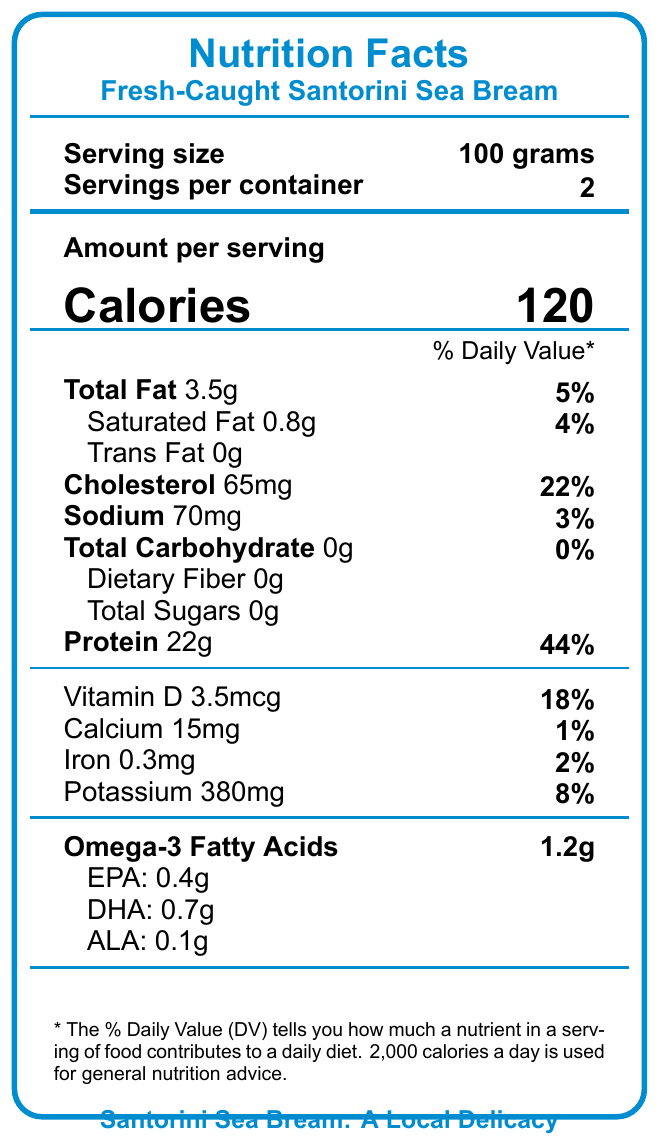how many calories are there per serving? The document lists "Calories" as 120 under the "Amount per serving" section.
Answer: 120 what is the total amount of omega-3 fatty acids in a serving? The "Omega-3 Fatty Acids" section shows a total of 1.2 grams.
Answer: 1.2g how much protein is in a serving of Santorini Sea Bream? The "Protein" amount is listed as 22 grams per serving.
Answer: 22g how much sodium is in one serving, and what is its daily value percentage? The document lists Sodium as 70mg, which is 3% of the daily value.
Answer: 70mg and 3% what is the serving size of Fresh-Caught Santorini Sea Bream? The document specifies the serving size as 100 grams.
Answer: 100 grams what percentage of the daily value is the vitamin D content per serving? Vitamin D amount is given as 18% of the daily value.
Answer: 18% which of the following nutrients is not present in the Fresh-Caught Santorini Sea Bream? A. Trans Fat B. Dietary Fiber C. Total Sugars D. All of the Above The document lists "Trans Fat" as 0g, "Dietary Fiber" as 0g, and "Total Sugars" as 0g, meaning none of these nutrients are present.
Answer: D. All of the Above which nutrient has the highest daily value percentage? A. Protein B. Cholesterol C. Calcium D. Potassium Among the listed nutrients, Protein has the highest daily value percentage at 44%.
Answer: A. Protein does the product contain any trans fat? The document clearly states "Trans Fat 0g".
Answer: No how many servings are per container? The document lists "Servings per container" as 2.
Answer: 2 what is the main idea of the document? The document outlines the nutritional content of Fresh-Caught Santorini Sea Bream, including specific details about its beneficial omega-3 fatty acids and mentions additional facts about the catch method and its local culinary importance.
Answer: The document provides the nutrition facts for Fresh-Caught Santorini Sea Bream, highlighting its serving size, calorie content, protein and fat amounts, and daily value percentages for various nutrients, along with additional information on its rich omega-3 fatty acids content and local significance. how is Fresh-Caught Santorini Sea Bream typically prepared in local cuisine according to the document? The document does not provide specific cooking methods or recipes for the sea bream; it only mentions its nutritional content and some local guide notes about its culinary importance.
Answer: Cannot be determined 